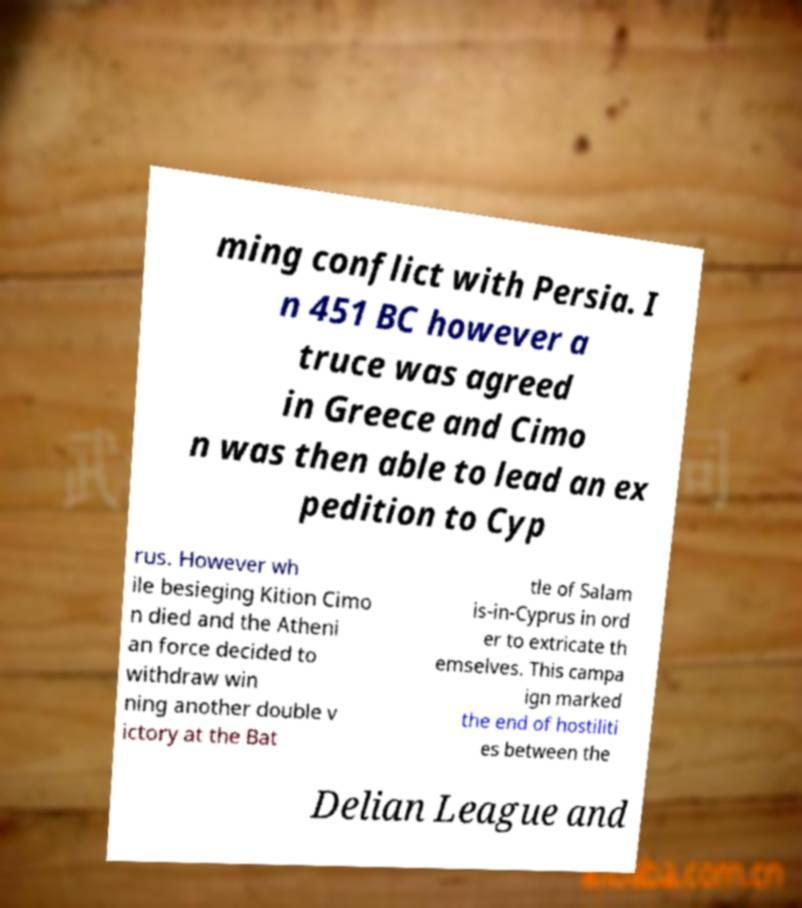Can you accurately transcribe the text from the provided image for me? ming conflict with Persia. I n 451 BC however a truce was agreed in Greece and Cimo n was then able to lead an ex pedition to Cyp rus. However wh ile besieging Kition Cimo n died and the Atheni an force decided to withdraw win ning another double v ictory at the Bat tle of Salam is-in-Cyprus in ord er to extricate th emselves. This campa ign marked the end of hostiliti es between the Delian League and 